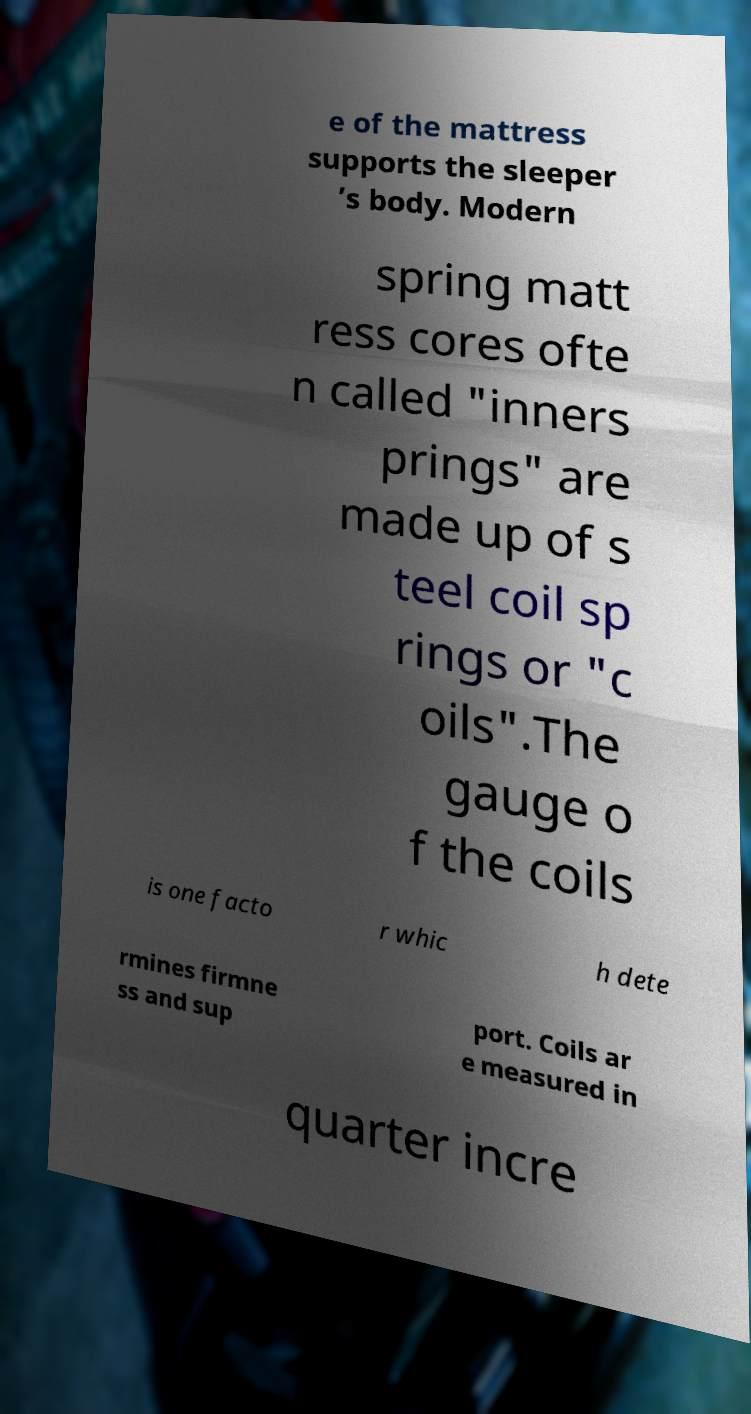Could you extract and type out the text from this image? e of the mattress supports the sleeper ’s body. Modern spring matt ress cores ofte n called "inners prings" are made up of s teel coil sp rings or "c oils".The gauge o f the coils is one facto r whic h dete rmines firmne ss and sup port. Coils ar e measured in quarter incre 